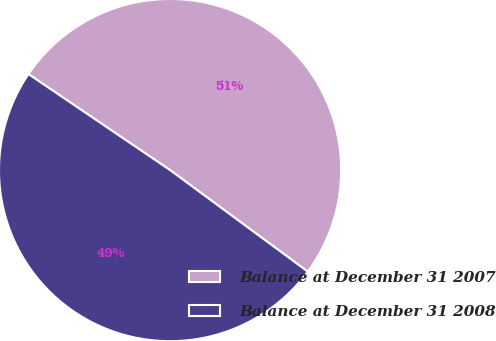Convert chart to OTSL. <chart><loc_0><loc_0><loc_500><loc_500><pie_chart><fcel>Balance at December 31 2007<fcel>Balance at December 31 2008<nl><fcel>50.63%<fcel>49.37%<nl></chart> 